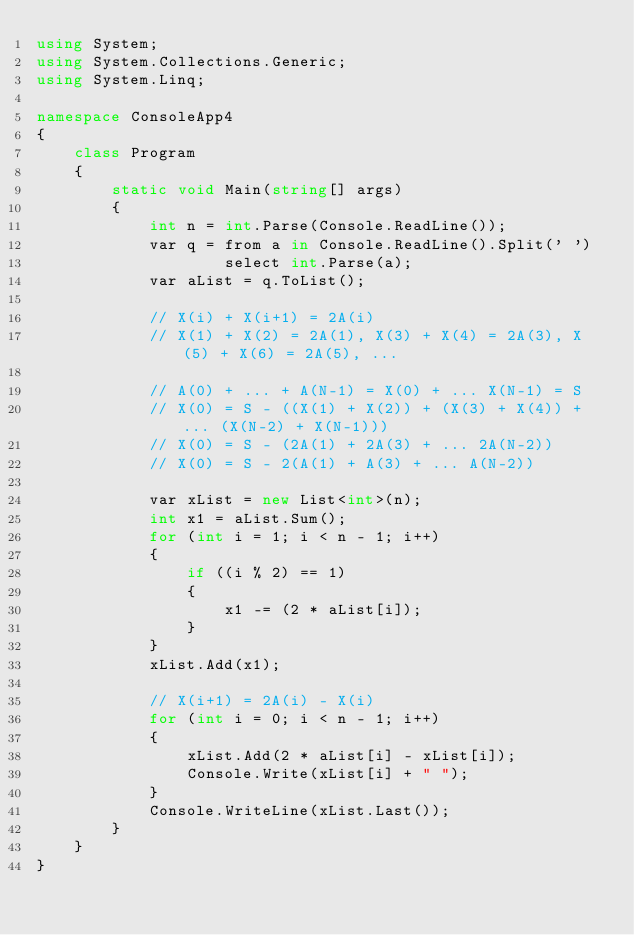Convert code to text. <code><loc_0><loc_0><loc_500><loc_500><_C#_>using System;
using System.Collections.Generic;
using System.Linq;

namespace ConsoleApp4
{
	class Program
	{
		static void Main(string[] args)
		{
			int n = int.Parse(Console.ReadLine());
			var q = from a in Console.ReadLine().Split(' ')
					select int.Parse(a);
			var aList = q.ToList();

			// X(i) + X(i+1) = 2A(i)
			// X(1) + X(2) = 2A(1), X(3) + X(4) = 2A(3), X(5) + X(6) = 2A(5), ...

			// A(0) + ... + A(N-1) = X(0) + ... X(N-1) = S
			// X(0) = S - ((X(1) + X(2)) + (X(3) + X(4)) + ... (X(N-2) + X(N-1)))
			// X(0) = S - (2A(1) + 2A(3) + ... 2A(N-2))
			// X(0) = S - 2(A(1) + A(3) + ... A(N-2))

			var xList = new List<int>(n);
			int x1 = aList.Sum();
			for (int i = 1; i < n - 1; i++)
			{
				if ((i % 2) == 1)
				{
					x1 -= (2 * aList[i]);
				}
			}
			xList.Add(x1);

			// X(i+1) = 2A(i) - X(i)
			for (int i = 0; i < n - 1; i++)
			{
				xList.Add(2 * aList[i] - xList[i]);
				Console.Write(xList[i] + " ");
			}
			Console.WriteLine(xList.Last());
		}
	}
}
</code> 